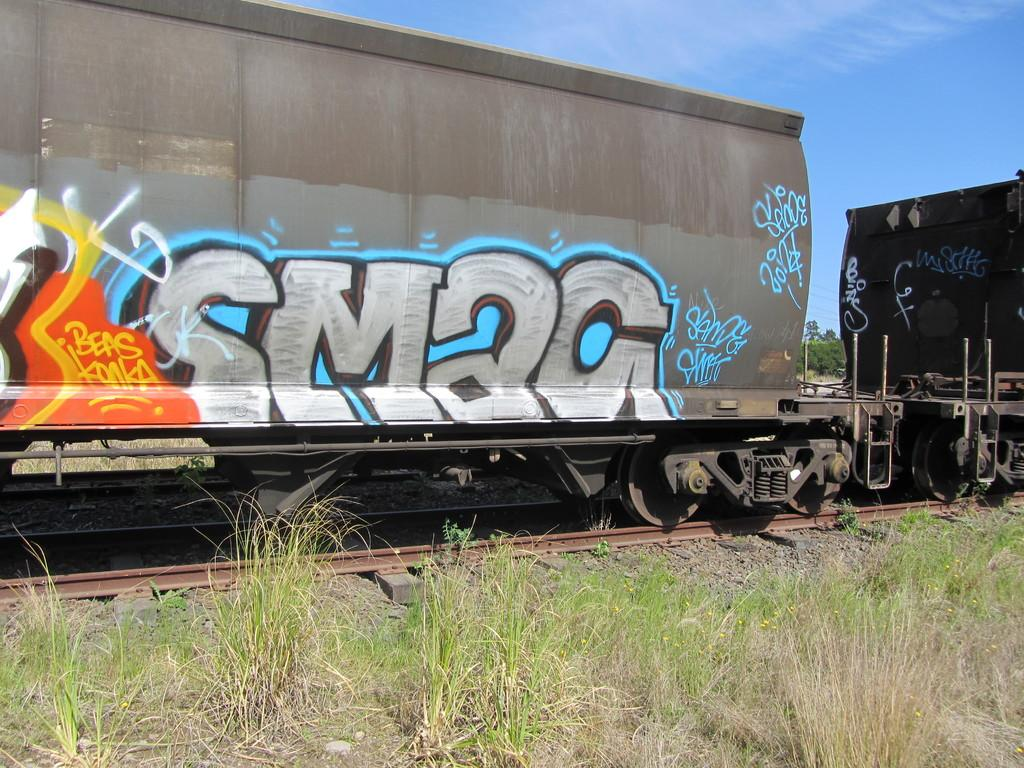What is the main subject in the middle of the image? There is a train in the middle of the image. What can be observed on the train? The train has paintings on it. What type of terrain is visible at the bottom of the image? There is grass at the bottom of the image. What is visible at the top of the image? The sky is visible at the top of the image. What scientific discovery was made during the operation of the train in the image? There is no indication of a scientific discovery or operation of the train in the image. 